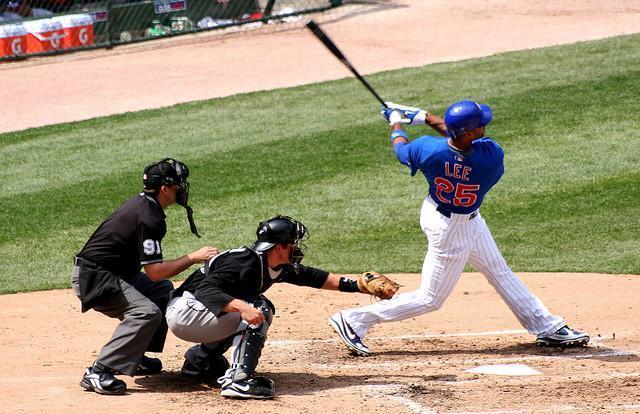How many people can be seen?
Give a very brief answer. 3. How many giraffes are there?
Give a very brief answer. 0. 